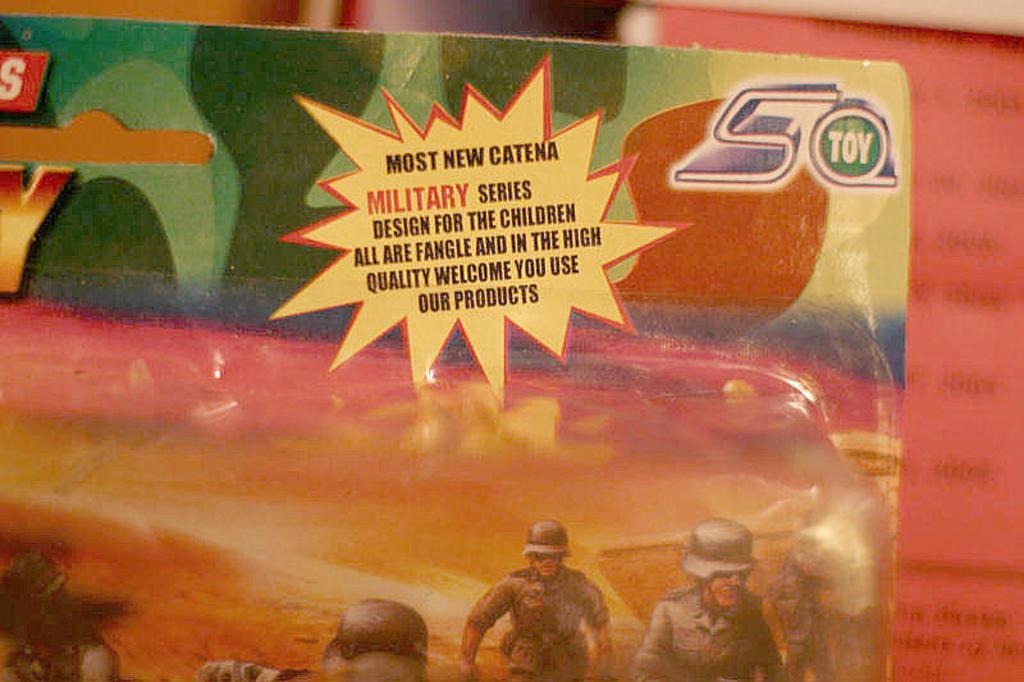How would you summarize this image in a sentence or two? In this image, we can see a poster, on the poster, we can see some pictures and text written on it. On the right side, we can see a book with some text written on it. 